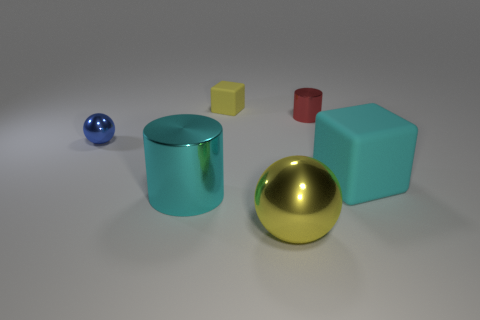The big metallic object that is the same color as the big rubber thing is what shape?
Offer a terse response. Cylinder. What number of small objects are balls or green metal things?
Offer a terse response. 1. How many objects are large things that are behind the cyan metal object or metallic objects?
Offer a terse response. 5. Is the small shiny ball the same color as the tiny rubber block?
Your answer should be compact. No. How many other things are the same shape as the cyan matte thing?
Your answer should be compact. 1. What number of cyan things are large cubes or tiny objects?
Your answer should be compact. 1. What color is the other cylinder that is made of the same material as the big cyan cylinder?
Ensure brevity in your answer.  Red. Do the yellow thing behind the blue sphere and the tiny object that is in front of the tiny cylinder have the same material?
Offer a terse response. No. There is a thing that is the same color as the large sphere; what is its size?
Keep it short and to the point. Small. There is a cyan object that is on the right side of the cyan metal thing; what material is it?
Keep it short and to the point. Rubber. 